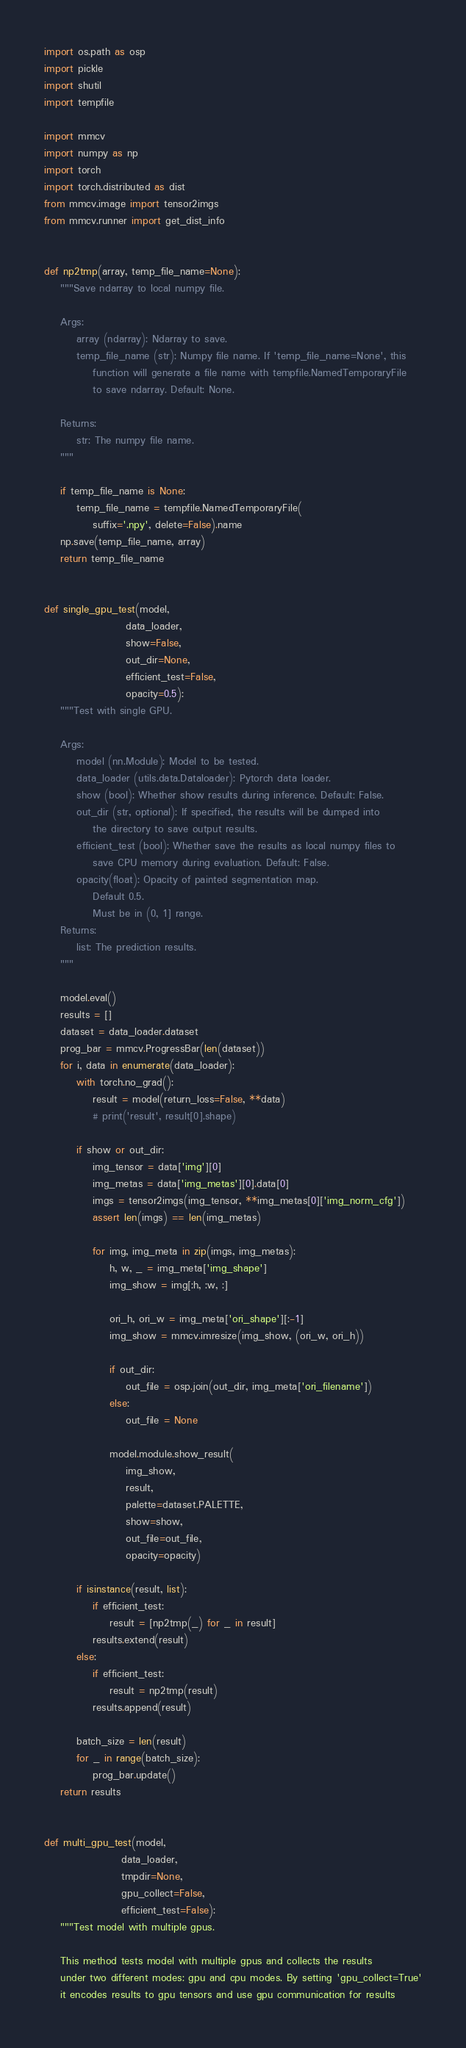Convert code to text. <code><loc_0><loc_0><loc_500><loc_500><_Python_>import os.path as osp
import pickle
import shutil
import tempfile

import mmcv
import numpy as np
import torch
import torch.distributed as dist
from mmcv.image import tensor2imgs
from mmcv.runner import get_dist_info


def np2tmp(array, temp_file_name=None):
    """Save ndarray to local numpy file.

    Args:
        array (ndarray): Ndarray to save.
        temp_file_name (str): Numpy file name. If 'temp_file_name=None', this
            function will generate a file name with tempfile.NamedTemporaryFile
            to save ndarray. Default: None.

    Returns:
        str: The numpy file name.
    """

    if temp_file_name is None:
        temp_file_name = tempfile.NamedTemporaryFile(
            suffix='.npy', delete=False).name
    np.save(temp_file_name, array)
    return temp_file_name


def single_gpu_test(model,
                    data_loader,
                    show=False,
                    out_dir=None,
                    efficient_test=False,
                    opacity=0.5):
    """Test with single GPU.

    Args:
        model (nn.Module): Model to be tested.
        data_loader (utils.data.Dataloader): Pytorch data loader.
        show (bool): Whether show results during inference. Default: False.
        out_dir (str, optional): If specified, the results will be dumped into
            the directory to save output results.
        efficient_test (bool): Whether save the results as local numpy files to
            save CPU memory during evaluation. Default: False.
        opacity(float): Opacity of painted segmentation map.
            Default 0.5.
            Must be in (0, 1] range.
    Returns:
        list: The prediction results.
    """

    model.eval()
    results = []
    dataset = data_loader.dataset
    prog_bar = mmcv.ProgressBar(len(dataset))
    for i, data in enumerate(data_loader):
        with torch.no_grad():
            result = model(return_loss=False, **data)
            # print('result', result[0].shape)

        if show or out_dir:
            img_tensor = data['img'][0]
            img_metas = data['img_metas'][0].data[0]
            imgs = tensor2imgs(img_tensor, **img_metas[0]['img_norm_cfg'])
            assert len(imgs) == len(img_metas)

            for img, img_meta in zip(imgs, img_metas):
                h, w, _ = img_meta['img_shape']
                img_show = img[:h, :w, :]

                ori_h, ori_w = img_meta['ori_shape'][:-1]
                img_show = mmcv.imresize(img_show, (ori_w, ori_h))

                if out_dir:
                    out_file = osp.join(out_dir, img_meta['ori_filename'])
                else:
                    out_file = None

                model.module.show_result(
                    img_show,
                    result,
                    palette=dataset.PALETTE,
                    show=show,
                    out_file=out_file,
                    opacity=opacity)

        if isinstance(result, list):
            if efficient_test:
                result = [np2tmp(_) for _ in result]
            results.extend(result)
        else:
            if efficient_test:
                result = np2tmp(result)
            results.append(result)

        batch_size = len(result)
        for _ in range(batch_size):
            prog_bar.update()
    return results


def multi_gpu_test(model,
                   data_loader,
                   tmpdir=None,
                   gpu_collect=False,
                   efficient_test=False):
    """Test model with multiple gpus.

    This method tests model with multiple gpus and collects the results
    under two different modes: gpu and cpu modes. By setting 'gpu_collect=True'
    it encodes results to gpu tensors and use gpu communication for results</code> 